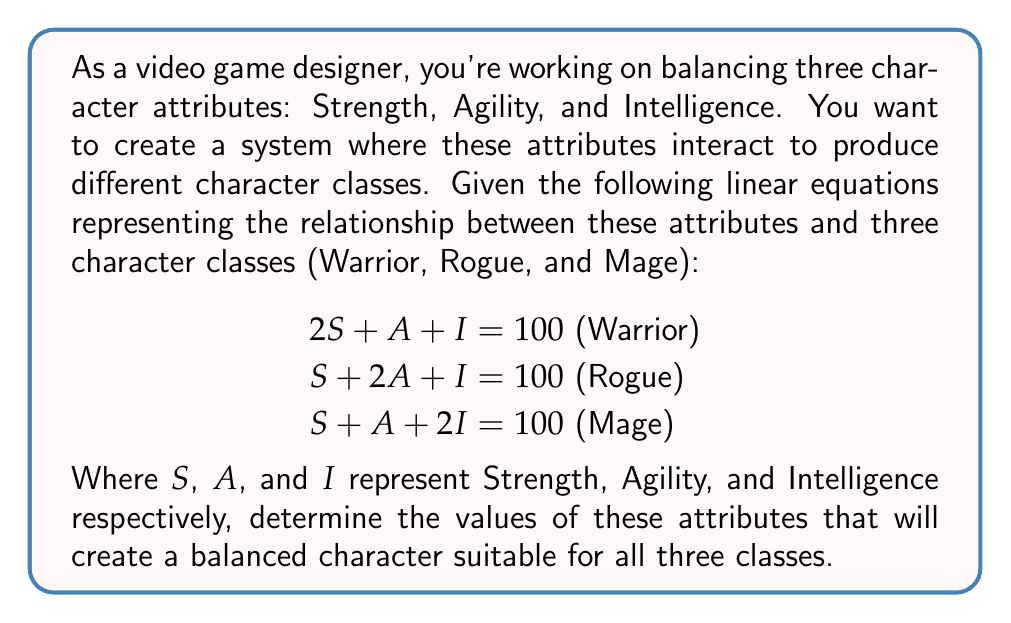Help me with this question. To solve this problem, we'll use linear algebra, specifically the concept of solving systems of linear equations using matrices.

1. First, let's represent our system of equations in matrix form:

   $$
   \begin{bmatrix}
   2 & 1 & 1 \\
   1 & 2 & 1 \\
   1 & 1 & 2
   \end{bmatrix}
   \begin{bmatrix}
   S \\
   A \\
   I
   \end{bmatrix}
   =
   \begin{bmatrix}
   100 \\
   100 \\
   100
   \end{bmatrix}
   $$

2. We can solve this using the inverse matrix method. Let's call our coefficient matrix $A$, our variable vector $X$, and our constant vector $B$. Then $AX = B$, and $X = A^{-1}B$.

3. To find $A^{-1}$, we can use the adjugate method or a calculator. The inverse of $A$ is:

   $$
   A^{-1} = \frac{1}{4}
   \begin{bmatrix}
   3 & -1 & -1 \\
   -1 & 3 & -1 \\
   -1 & -1 & 3
   \end{bmatrix}
   $$

4. Now we can solve for $X$:

   $$
   X = A^{-1}B = \frac{1}{4}
   \begin{bmatrix}
   3 & -1 & -1 \\
   -1 & 3 & -1 \\
   -1 & -1 & 3
   \end{bmatrix}
   \begin{bmatrix}
   100 \\
   100 \\
   100
   \end{bmatrix}
   $$

5. Multiplying these matrices:

   $$
   X = \frac{1}{4}
   \begin{bmatrix}
   3(100) + (-1)(100) + (-1)(100) \\
   (-1)(100) + 3(100) + (-1)(100) \\
   (-1)(100) + (-1)(100) + 3(100)
   \end{bmatrix}
   = \frac{1}{4}
   \begin{bmatrix}
   100 \\
   100 \\
   100
   \end{bmatrix}
   = \begin{bmatrix}
   25 \\
   25 \\
   25
   \end{bmatrix}
   $$

Therefore, the balanced attributes are: Strength = 25, Agility = 25, and Intelligence = 25.
Answer: $S = 25$, $A = 25$, $I = 25$ 